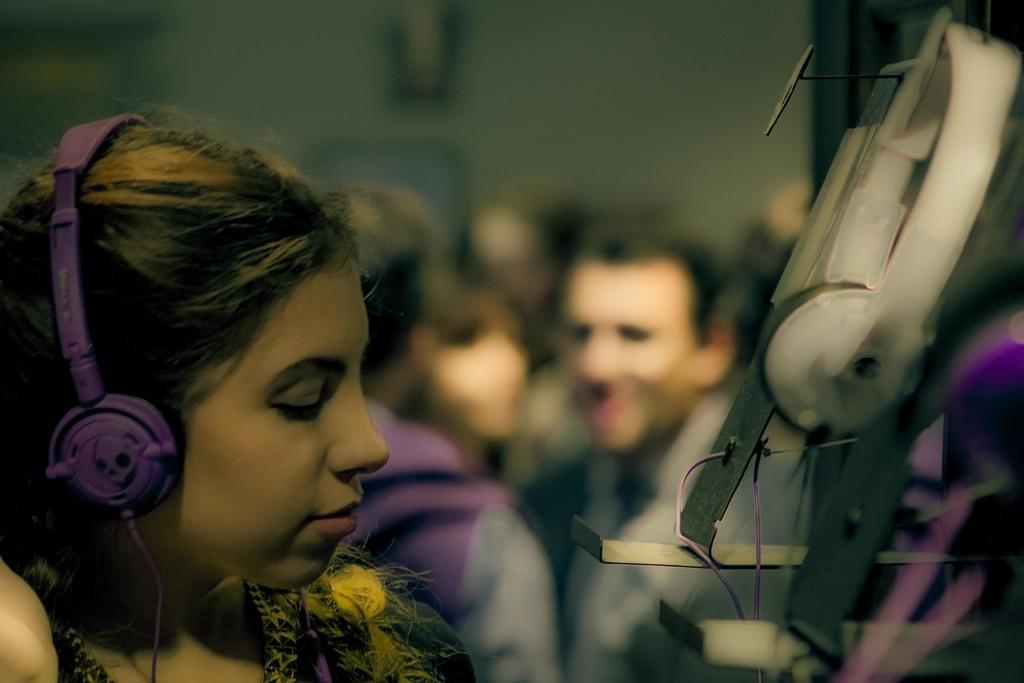Can you describe this image briefly? In this image, we can see a woman, she is wearing the headphone, in the background we can see some people standing. 